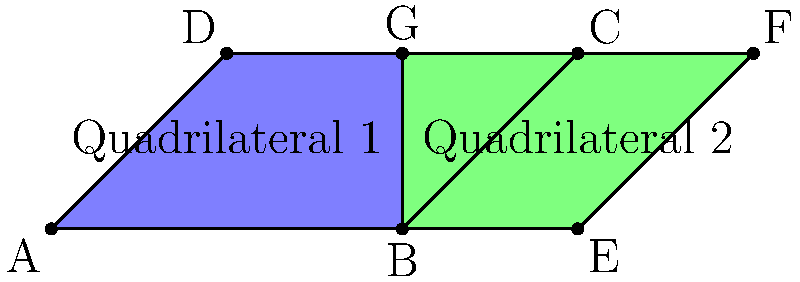In the tessellation pattern shown above, Quadrilateral 1 (ABCD) and Quadrilateral 2 (BEFG) share a common side. Prove that these quadrilaterals are congruent by identifying the appropriate congruence criterion and explaining your reasoning. To prove that Quadrilateral 1 (ABCD) and Quadrilateral 2 (BEFG) are congruent, we'll use the Side-Angle-Side (SAS) congruence criterion. Let's follow these steps:

1) Identify the shared side:
   Side BC of Quadrilateral 1 is the same as side BE of Quadrilateral 2.

2) Identify corresponding angles:
   Angle ABC in Quadrilateral 1 corresponds to angle EBG in Quadrilateral 2.
   Angle BCD in Quadrilateral 1 corresponds to angle BEF in Quadrilateral 2.

3) Prove that these corresponding angles are congruent:
   - In a tessellation, adjacent shapes fit together without gaps or overlaps.
   - Therefore, $\angle ABC + \angle EBG = 180°$ (linear pair).
   - Similarly, $\angle BCD + \angle BEF = 180°$ (linear pair).
   - In a quadrilateral, opposite angles are supplementary, so:
     $\angle ABC + \angle BCD = 180°$ and $\angle EBG + \angle BEF = 180°$
   - From these equations, we can conclude that $\angle ABC \cong \angle EBG$ and $\angle BCD \cong \angle BEF$.

4) Identify another pair of corresponding sides:
   Side AB in Quadrilateral 1 corresponds to side BG in Quadrilateral 2.
   Side CD in Quadrilateral 1 corresponds to side EF in Quadrilateral 2.

5) Prove that these corresponding sides are congruent:
   - In a tessellation, corresponding sides of adjacent shapes must be equal in length for the pattern to repeat.
   - Therefore, AB ≅ BG and CD ≅ EF.

6) Apply the SAS congruence criterion:
   - We have shown that:
     a) BC ≅ BE (shared side)
     b) $\angle ABC \cong \angle EBG$ (corresponding angles)
     c) AB ≅ BG (corresponding sides)
   - This satisfies the SAS congruence criterion.

Therefore, by the SAS congruence criterion, Quadrilateral 1 (ABCD) is congruent to Quadrilateral 2 (BEFG).
Answer: SAS congruence criterion: BC ≅ BE, $\angle ABC \cong \angle EBG$, AB ≅ BG 